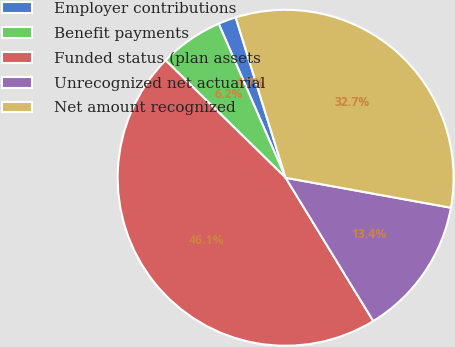Convert chart to OTSL. <chart><loc_0><loc_0><loc_500><loc_500><pie_chart><fcel>Employer contributions<fcel>Benefit payments<fcel>Funded status (plan assets<fcel>Unrecognized net actuarial<fcel>Net amount recognized<nl><fcel>1.72%<fcel>6.15%<fcel>46.06%<fcel>13.41%<fcel>32.66%<nl></chart> 